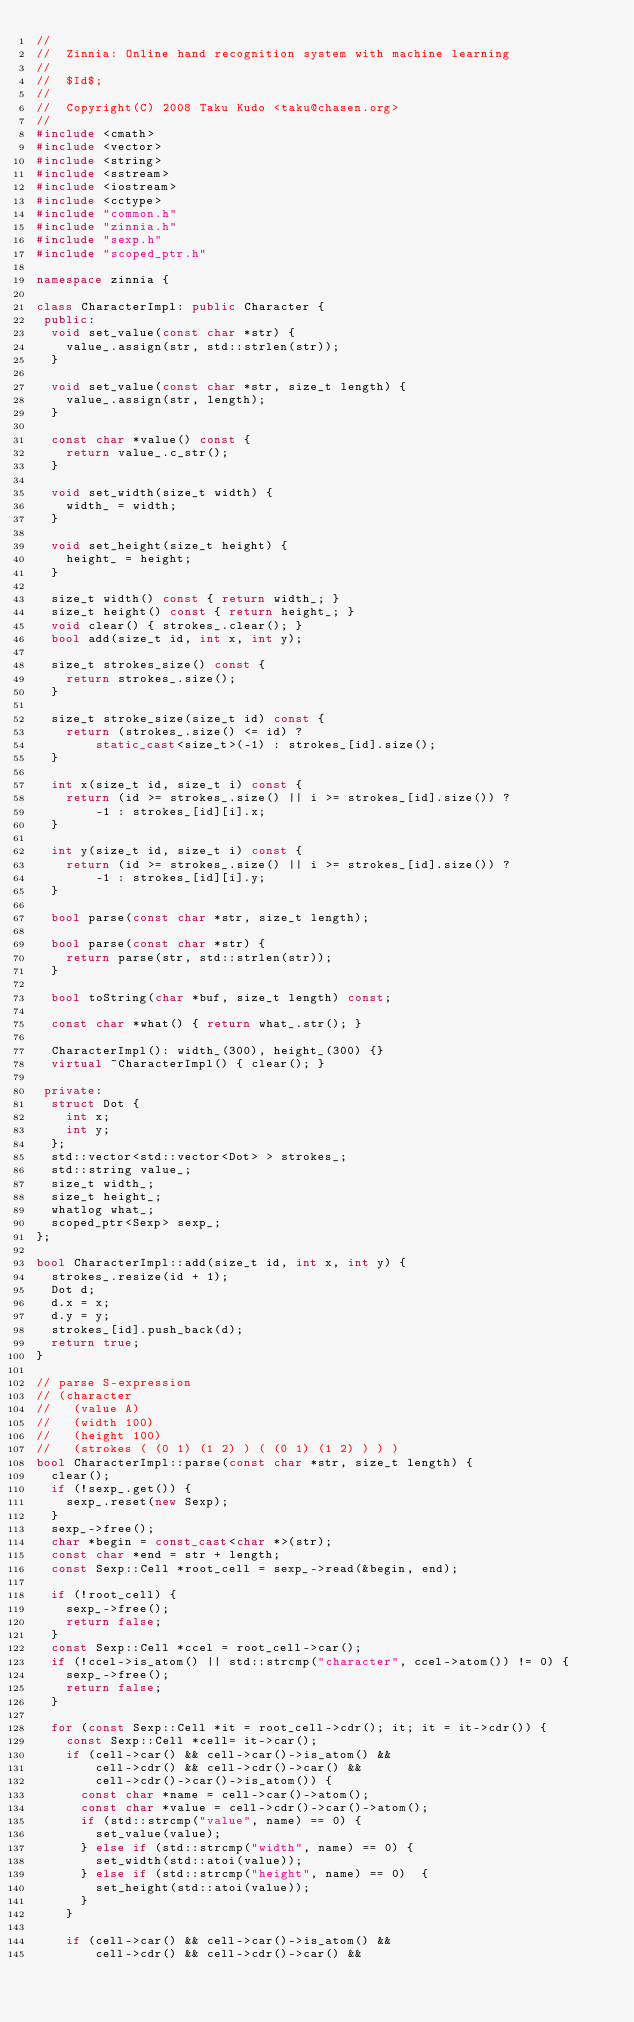Convert code to text. <code><loc_0><loc_0><loc_500><loc_500><_C++_>//
//  Zinnia: Online hand recognition system with machine learning
//
//  $Id$;
//
//  Copyright(C) 2008 Taku Kudo <taku@chasen.org>
//
#include <cmath>
#include <vector>
#include <string>
#include <sstream>
#include <iostream>
#include <cctype>
#include "common.h"
#include "zinnia.h"
#include "sexp.h"
#include "scoped_ptr.h"

namespace zinnia {

class CharacterImpl: public Character {
 public:
  void set_value(const char *str) {
    value_.assign(str, std::strlen(str));
  }

  void set_value(const char *str, size_t length) {
    value_.assign(str, length);
  }

  const char *value() const {
    return value_.c_str();
  }

  void set_width(size_t width) {
    width_ = width;
  }

  void set_height(size_t height) {
    height_ = height;
  }

  size_t width() const { return width_; }
  size_t height() const { return height_; }
  void clear() { strokes_.clear(); }
  bool add(size_t id, int x, int y);

  size_t strokes_size() const {
    return strokes_.size();
  }

  size_t stroke_size(size_t id) const {
    return (strokes_.size() <= id) ?
        static_cast<size_t>(-1) : strokes_[id].size();
  }

  int x(size_t id, size_t i) const {
    return (id >= strokes_.size() || i >= strokes_[id].size()) ?
        -1 : strokes_[id][i].x;
  }

  int y(size_t id, size_t i) const {
    return (id >= strokes_.size() || i >= strokes_[id].size()) ?
        -1 : strokes_[id][i].y;
  }

  bool parse(const char *str, size_t length);

  bool parse(const char *str) {
    return parse(str, std::strlen(str));
  }

  bool toString(char *buf, size_t length) const;

  const char *what() { return what_.str(); }

  CharacterImpl(): width_(300), height_(300) {}
  virtual ~CharacterImpl() { clear(); }

 private:
  struct Dot {
    int x;
    int y;
  };
  std::vector<std::vector<Dot> > strokes_;
  std::string value_;
  size_t width_;
  size_t height_;
  whatlog what_;
  scoped_ptr<Sexp> sexp_;
};

bool CharacterImpl::add(size_t id, int x, int y) {
  strokes_.resize(id + 1);
  Dot d;
  d.x = x;
  d.y = y;
  strokes_[id].push_back(d);
  return true;
}

// parse S-expression
// (character
//   (value A)
//   (width 100)
//   (height 100)
//   (strokes ( (0 1) (1 2) ) ( (0 1) (1 2) ) ) )
bool CharacterImpl::parse(const char *str, size_t length) {
  clear();
  if (!sexp_.get()) {
    sexp_.reset(new Sexp);
  }
  sexp_->free();
  char *begin = const_cast<char *>(str);
  const char *end = str + length;
  const Sexp::Cell *root_cell = sexp_->read(&begin, end);

  if (!root_cell) {
    sexp_->free();
    return false;
  }
  const Sexp::Cell *ccel = root_cell->car();
  if (!ccel->is_atom() || std::strcmp("character", ccel->atom()) != 0) {
    sexp_->free();
    return false;
  }

  for (const Sexp::Cell *it = root_cell->cdr(); it; it = it->cdr()) {
    const Sexp::Cell *cell= it->car();
    if (cell->car() && cell->car()->is_atom() &&
        cell->cdr() && cell->cdr()->car() &&
        cell->cdr()->car()->is_atom()) {
      const char *name = cell->car()->atom();
      const char *value = cell->cdr()->car()->atom();
      if (std::strcmp("value", name) == 0) {
        set_value(value);
      } else if (std::strcmp("width", name) == 0) {
        set_width(std::atoi(value));
      } else if (std::strcmp("height", name) == 0)  {
        set_height(std::atoi(value));
      }
    }

    if (cell->car() && cell->car()->is_atom() &&
        cell->cdr() && cell->cdr()->car() &&</code> 